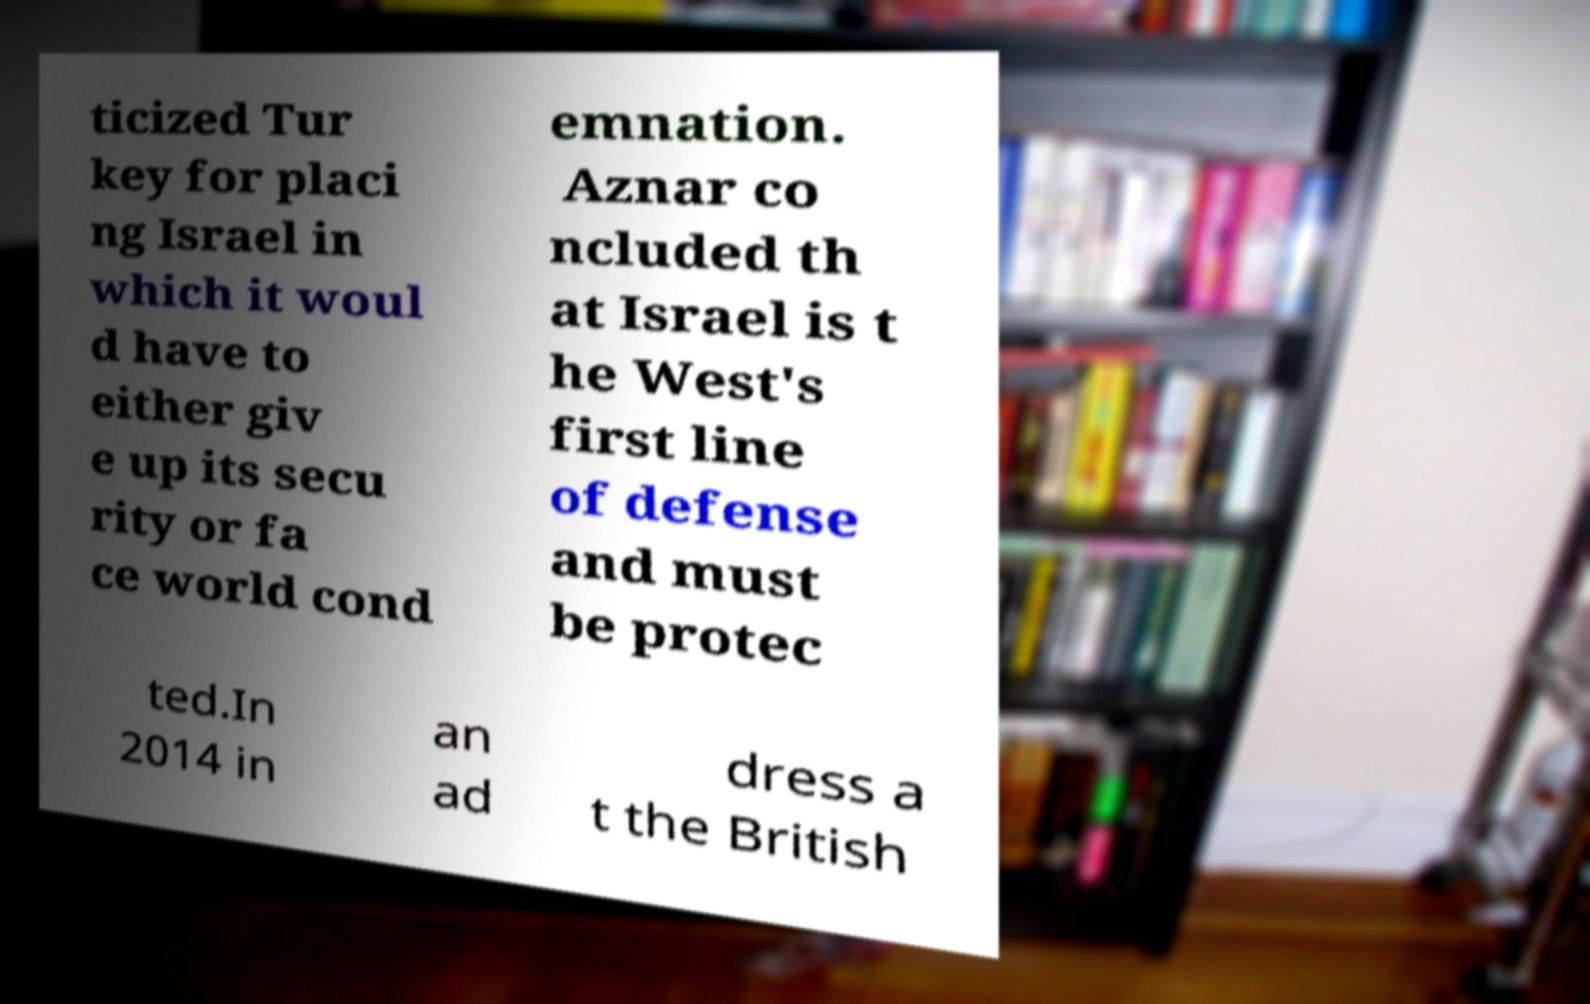Could you extract and type out the text from this image? ticized Tur key for placi ng Israel in which it woul d have to either giv e up its secu rity or fa ce world cond emnation. Aznar co ncluded th at Israel is t he West's first line of defense and must be protec ted.In 2014 in an ad dress a t the British 